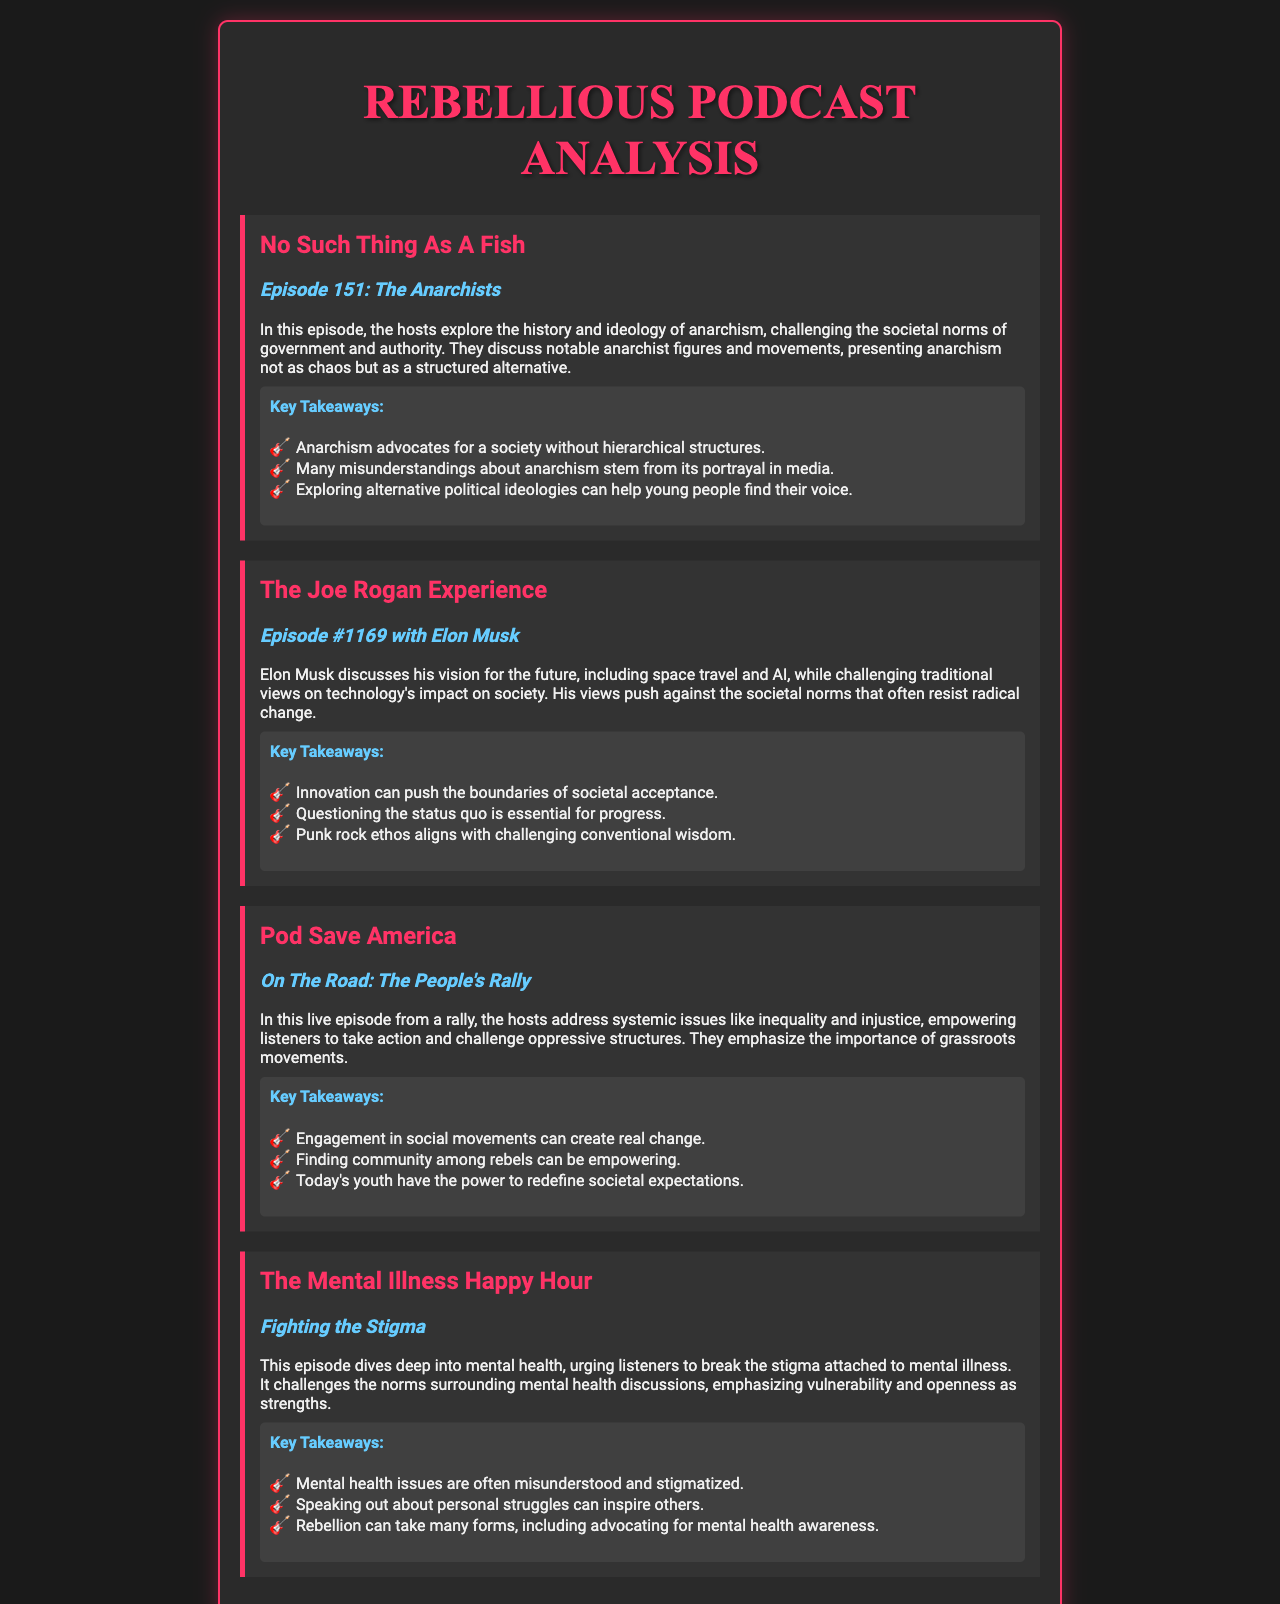What is the title of the first podcast analyzed? The title is located at the beginning of the first podcast section.
Answer: No Such Thing As A Fish What is the episode number of "The Joe Rogan Experience"? The episode number is clearly stated in the title of the second podcast section.
Answer: Episode #1169 Who was the guest in the episode of "The Joe Rogan Experience"? The guest's name is mentioned in the title of the podcast episode.
Answer: Elon Musk What is the main topic discussed in "Fighting the Stigma"? The main topic is found in the brief description of the fourth podcast section.
Answer: Mental health What is one key takeaway from the episode "The Anarchists"? The key takeaway is summarized in the key takeaways list following the episode description.
Answer: Anarchism advocates for a society without hierarchical structures What societal issue is addressed in "On The Road: The People's Rally"? The specific societal issue is mentioned in the overview of the third podcast episode.
Answer: Inequality and injustice Which podcast signifies a challenge to traditional views on technology? The title of the podcast that challenges those views is included in the document.
Answer: The Joe Rogan Experience How many key takeaways are listed for "The Mental Illness Happy Hour"? The number of key takeaways can be found in the outlined key takeaways section of the episode description.
Answer: Three What color is used for the podcast titles? The document specifies the color used for the podcast titles within the styling section.
Answer: #ff3366 